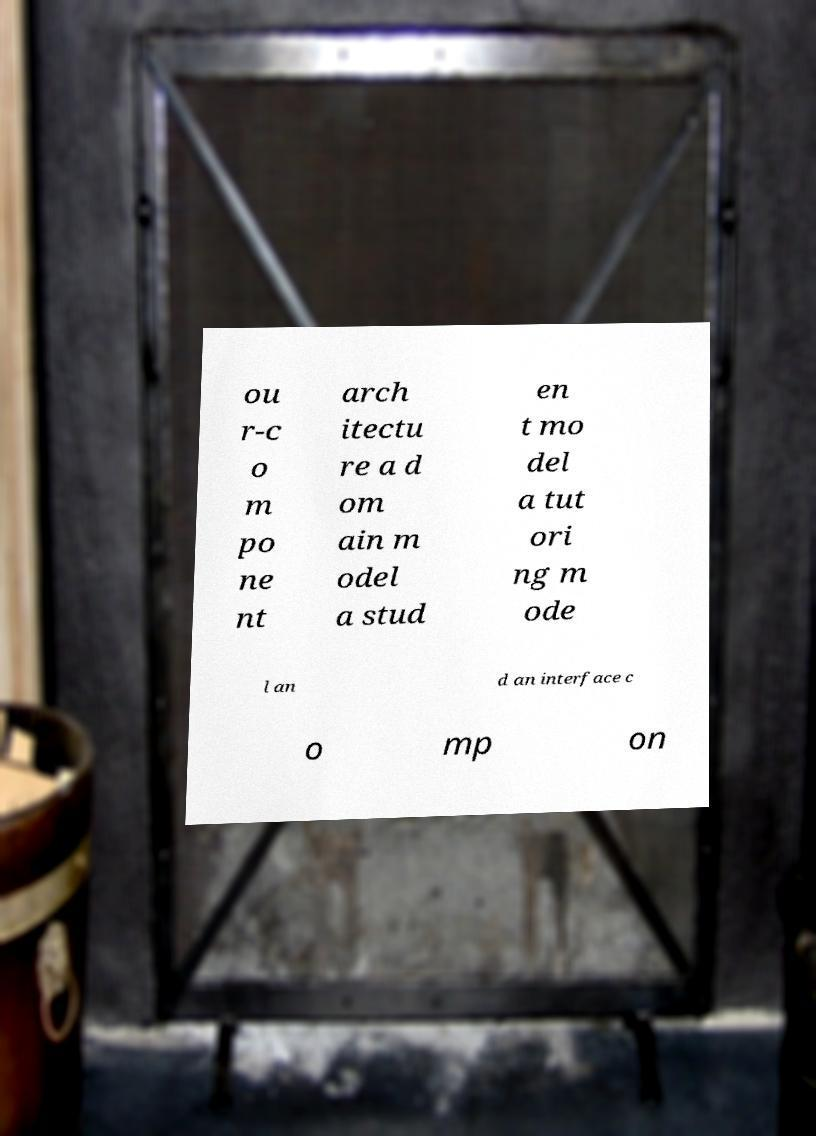Please identify and transcribe the text found in this image. ou r-c o m po ne nt arch itectu re a d om ain m odel a stud en t mo del a tut ori ng m ode l an d an interface c o mp on 